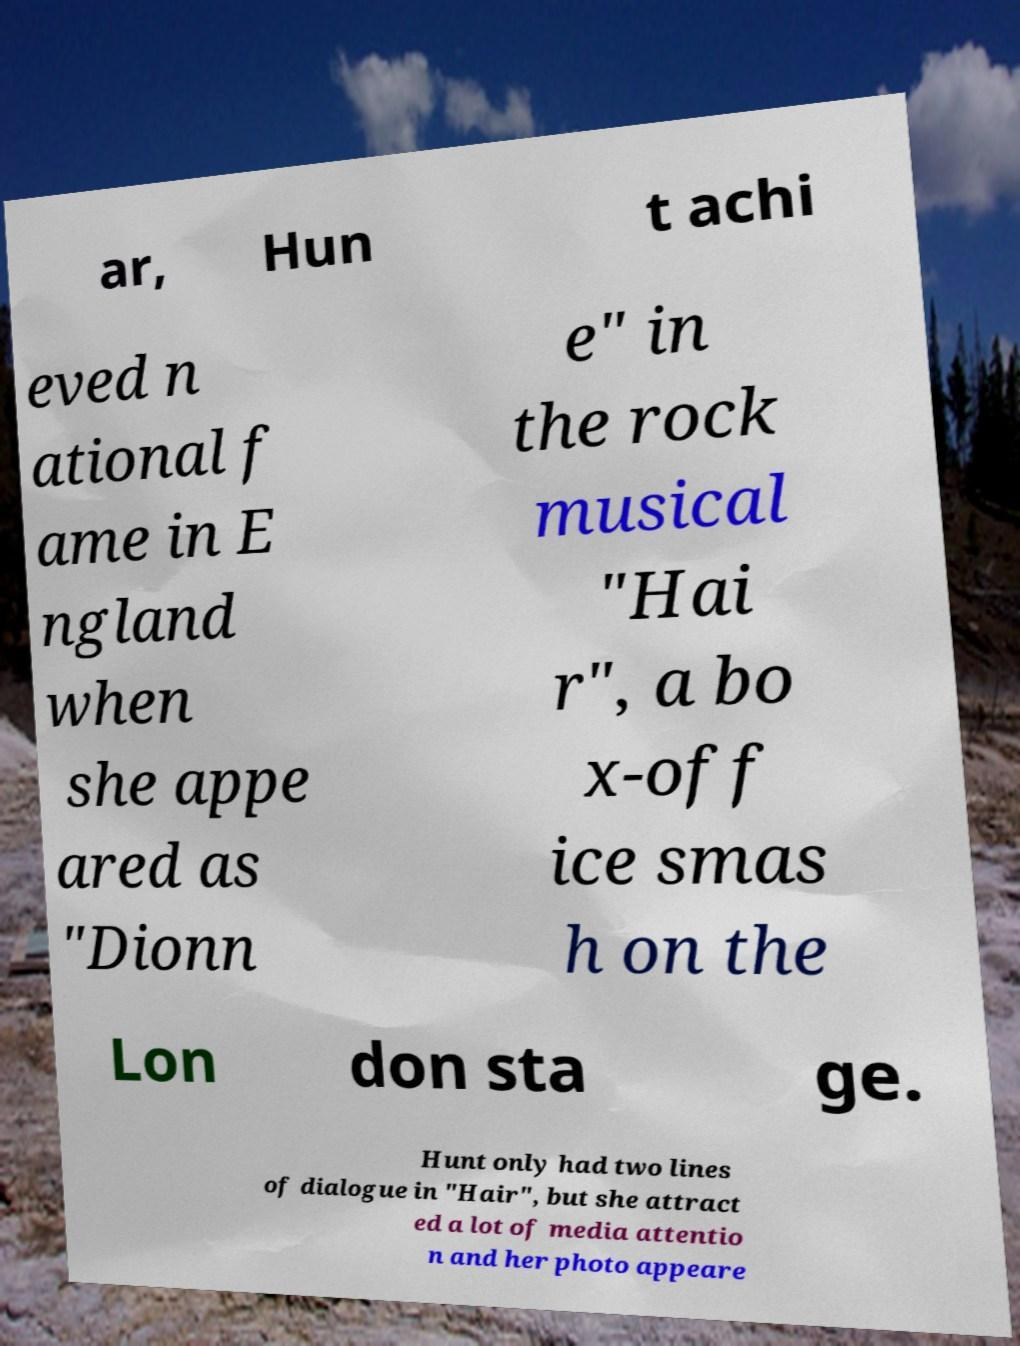There's text embedded in this image that I need extracted. Can you transcribe it verbatim? ar, Hun t achi eved n ational f ame in E ngland when she appe ared as "Dionn e" in the rock musical "Hai r", a bo x-off ice smas h on the Lon don sta ge. Hunt only had two lines of dialogue in "Hair", but she attract ed a lot of media attentio n and her photo appeare 